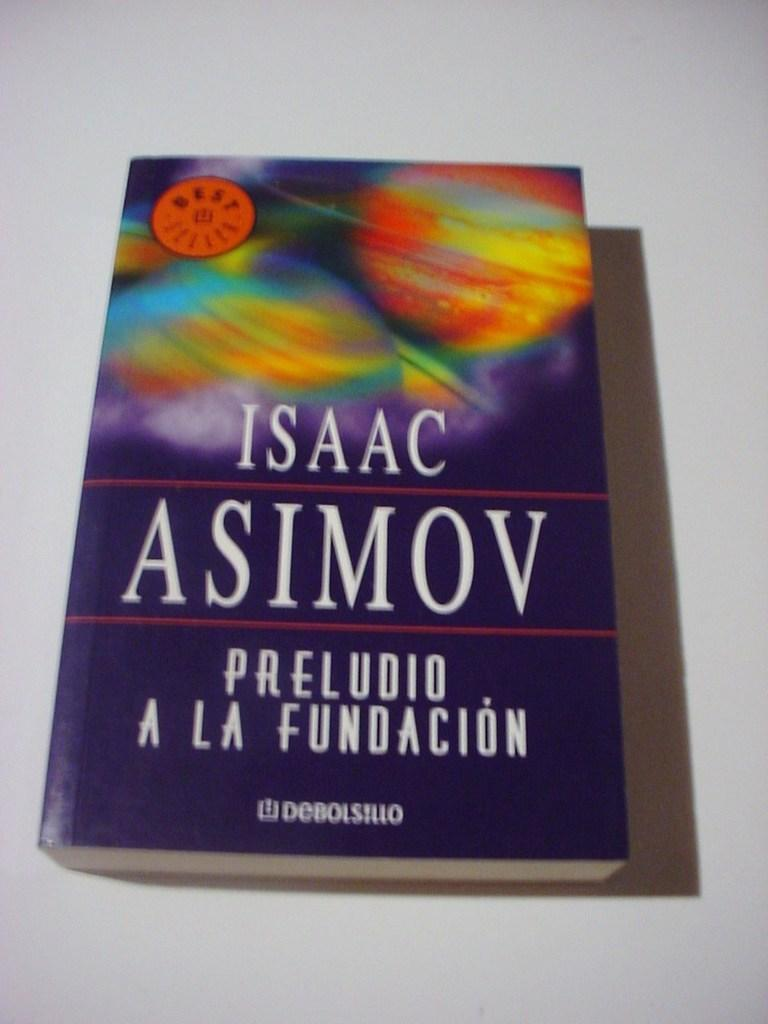<image>
Share a concise interpretation of the image provided. A paperback book by Isaac Asimov has a purple cover with swipes of yellows, reds and blues. 